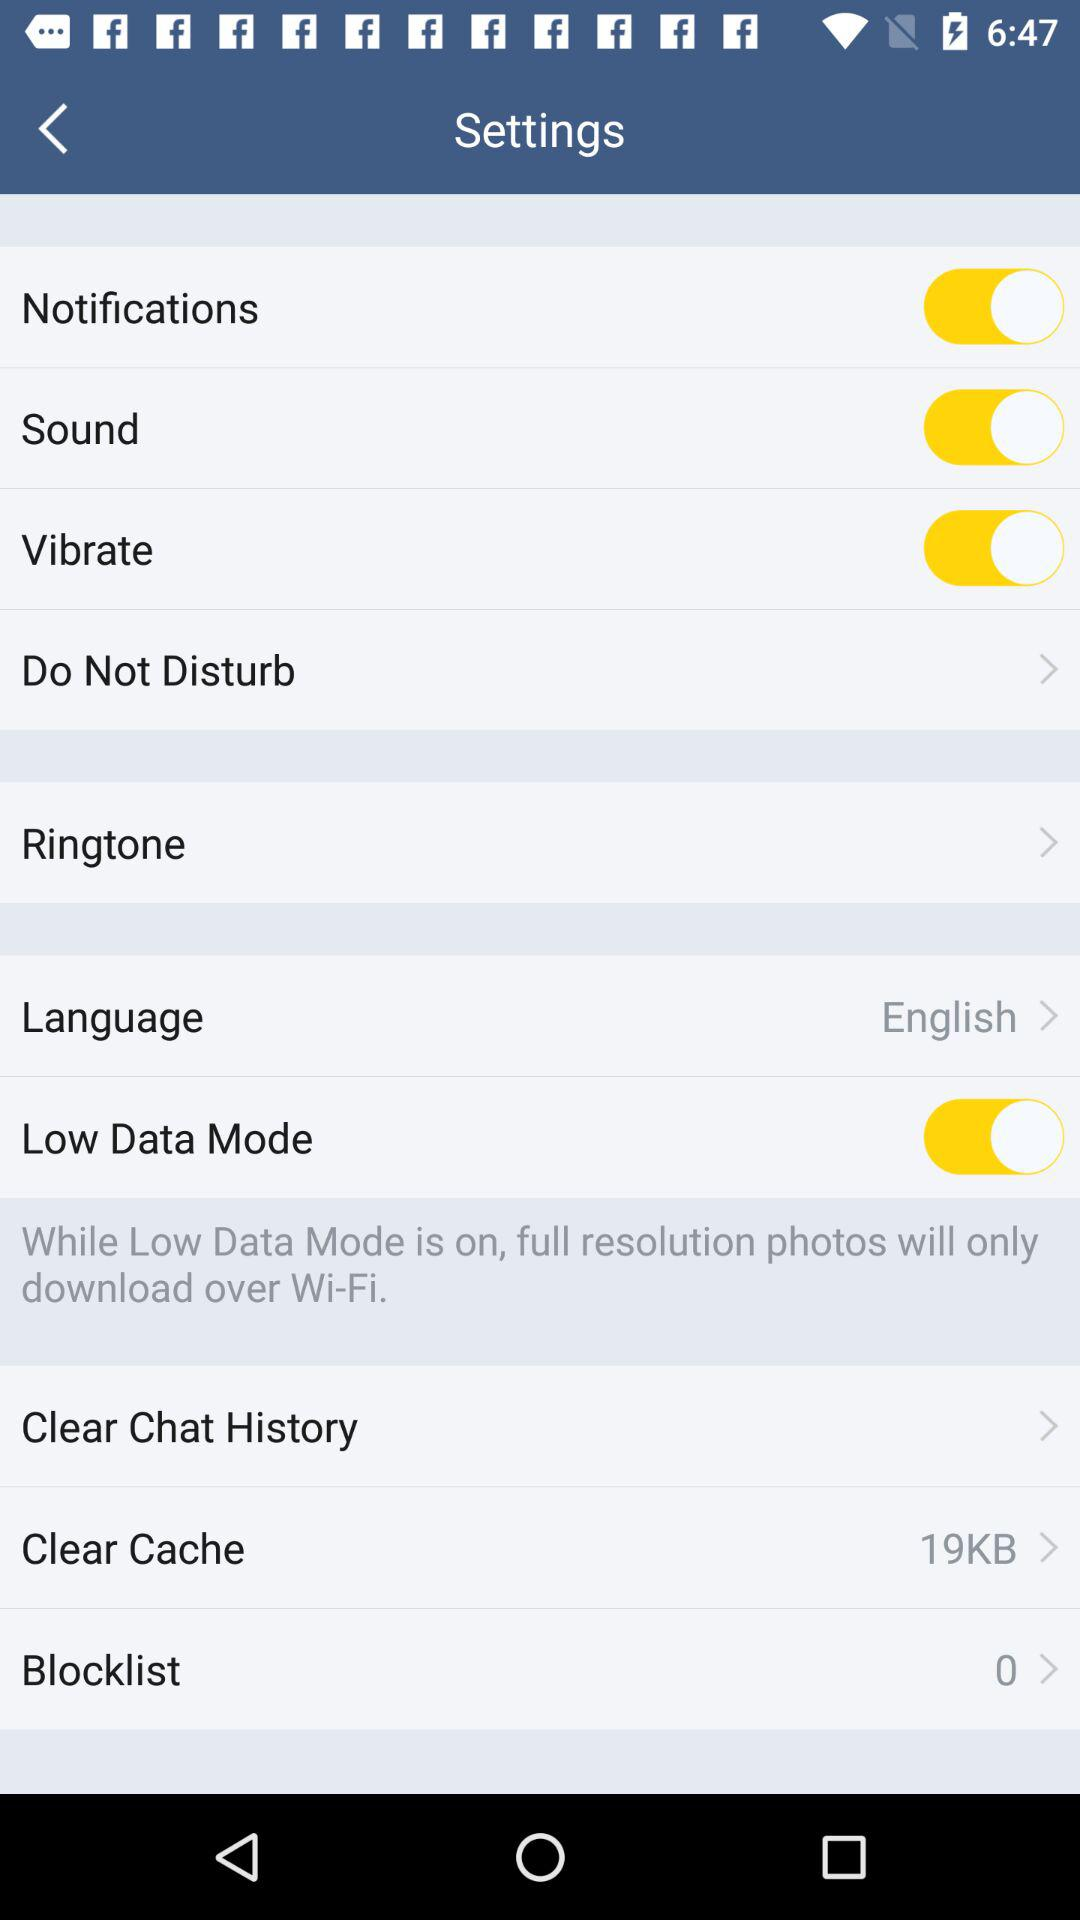How many contacts in the blocklist are there? There are 0 contacts in the blocklist. 